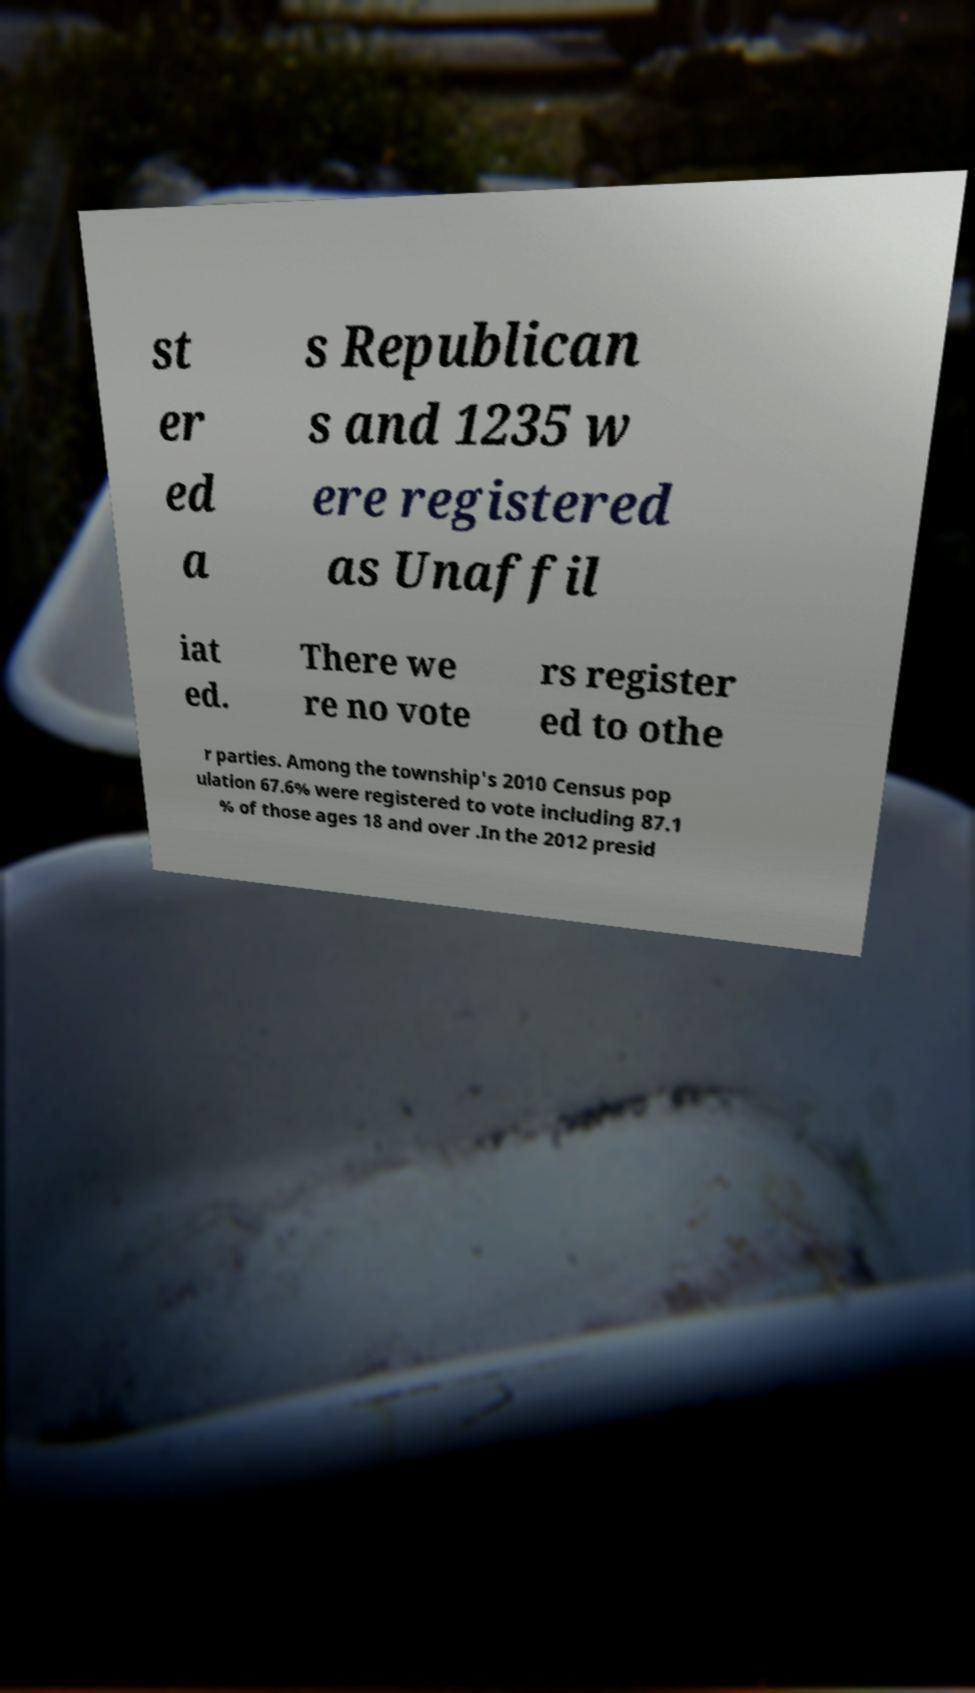Could you extract and type out the text from this image? st er ed a s Republican s and 1235 w ere registered as Unaffil iat ed. There we re no vote rs register ed to othe r parties. Among the township's 2010 Census pop ulation 67.6% were registered to vote including 87.1 % of those ages 18 and over .In the 2012 presid 